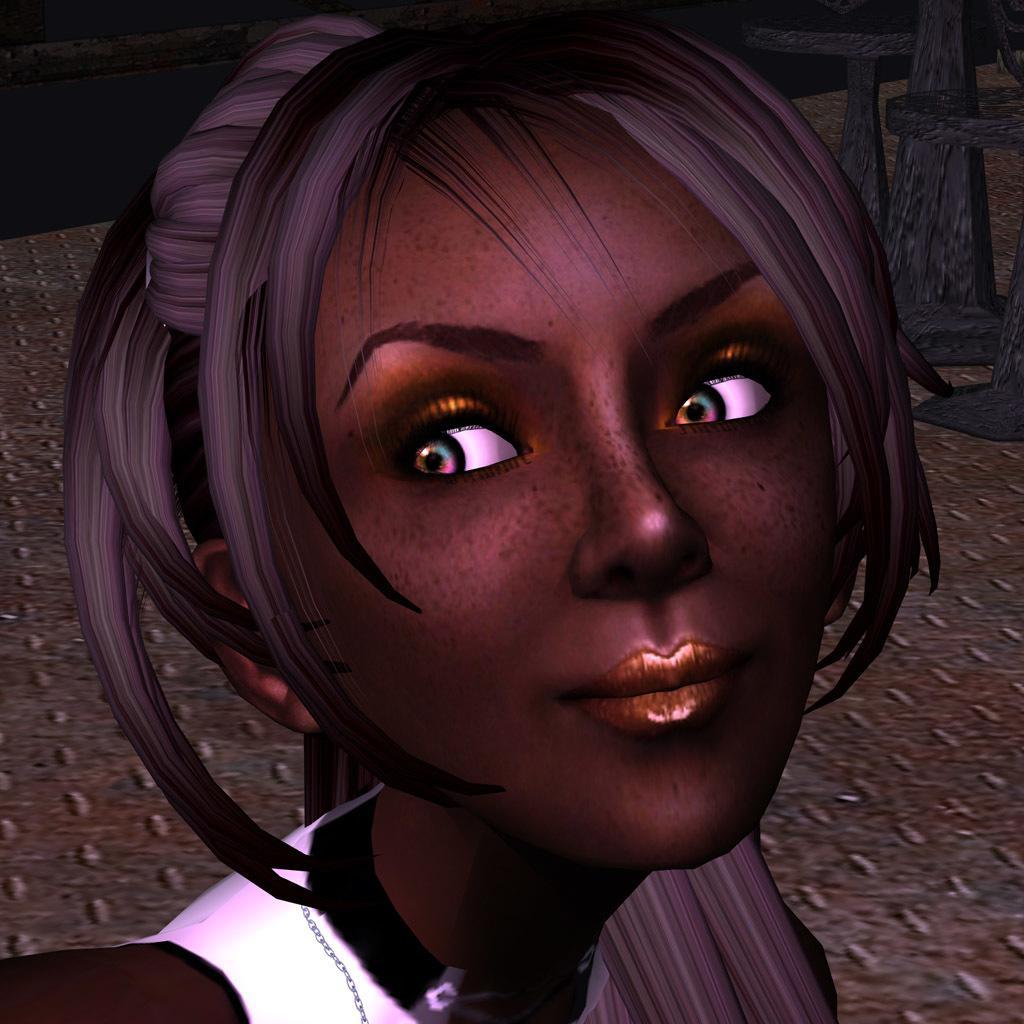Can you describe this image briefly? This is an animated image. In this image we can see a woman. In the back there are some objects. 